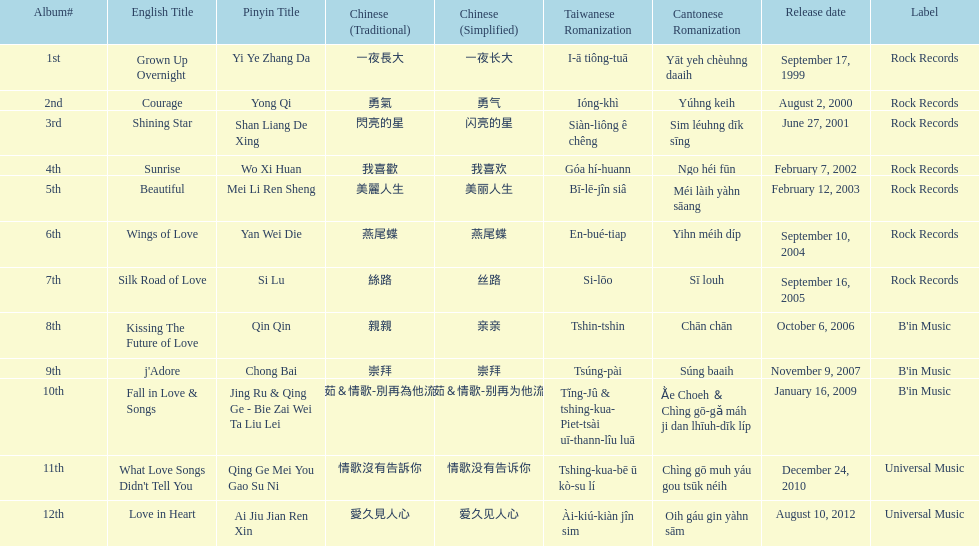What is the name of her last album produced with rock records? Silk Road of Love. 